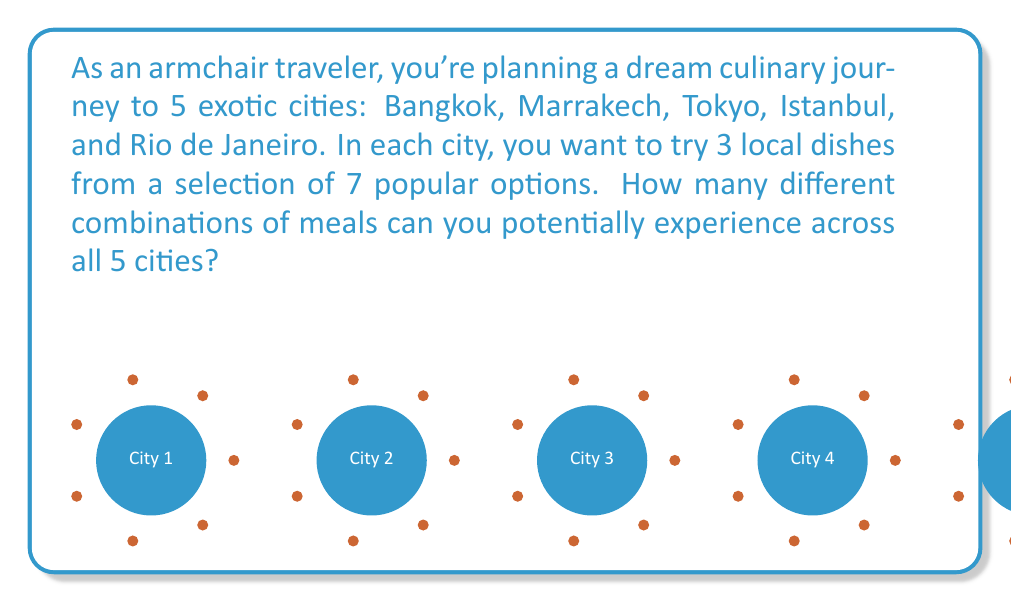Solve this math problem. Let's break this down step-by-step:

1) For each city, we need to choose 3 dishes out of 7 options. This is a combination problem, denoted as $C(7,3)$ or $\binom{7}{3}$.

2) The number of ways to choose 3 items from 7 is calculated as:

   $$\binom{7}{3} = \frac{7!}{3!(7-3)!} = \frac{7!}{3!4!} = 35$$

3) This means for each city, there are 35 different ways to choose 3 dishes.

4) Since we're doing this for 5 different cities, and the choices in each city are independent of the others, we multiply the number of possibilities for each city:

   $$35 \times 35 \times 35 \times 35 \times 35 = 35^5$$

5) We can calculate this:

   $$35^5 = 52,521,875$$

Therefore, there are 52,521,875 different combinations of meals you can potentially experience across all 5 cities.
Answer: $35^5 = 52,521,875$ 